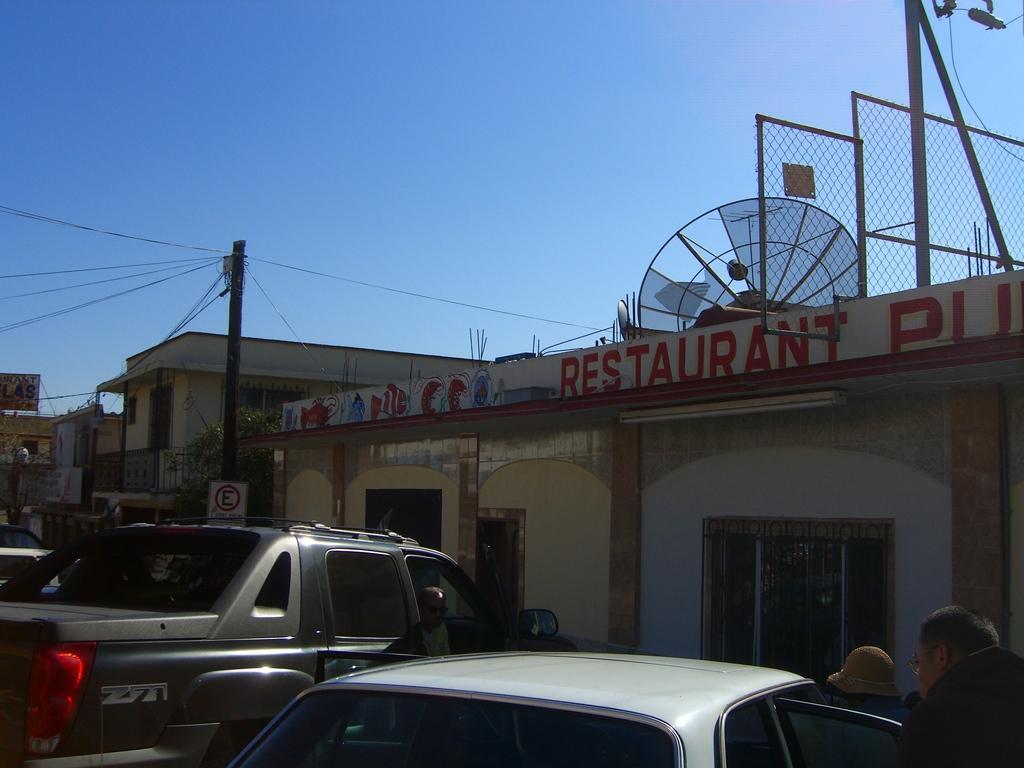Please provide a concise description of this image. In this picture we can see two vehicles here, on the right there are buildings, we can see satellite dish here, there is a pole and a board here, we can see wires here, at the right bottom there is a person, we can see the sky at the top of the picture. 